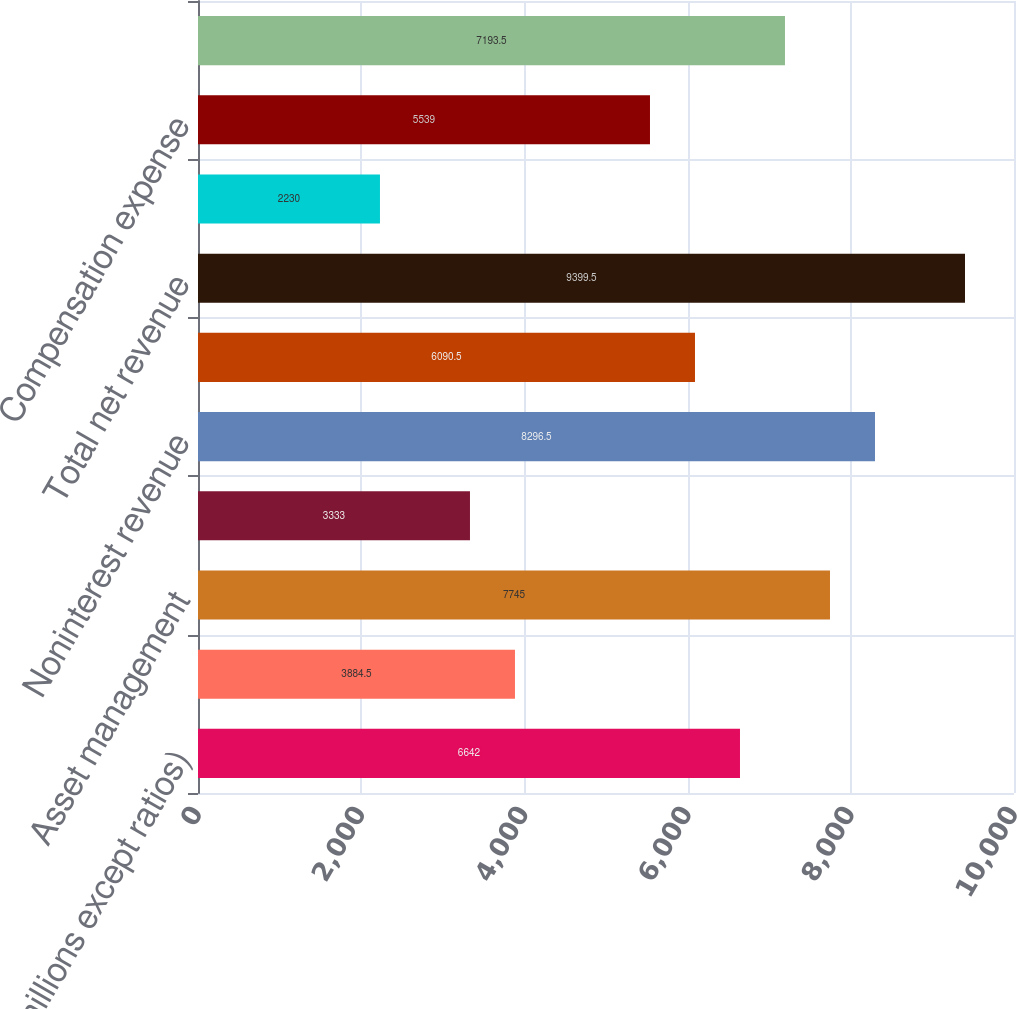Convert chart. <chart><loc_0><loc_0><loc_500><loc_500><bar_chart><fcel>(in millions except ratios)<fcel>Lending & deposit-related fees<fcel>Asset management<fcel>All other income<fcel>Noninterest revenue<fcel>Net interest income<fcel>Total net revenue<fcel>Credit reimbursement to IB (a)<fcel>Compensation expense<fcel>Noncompensation expense<nl><fcel>6642<fcel>3884.5<fcel>7745<fcel>3333<fcel>8296.5<fcel>6090.5<fcel>9399.5<fcel>2230<fcel>5539<fcel>7193.5<nl></chart> 